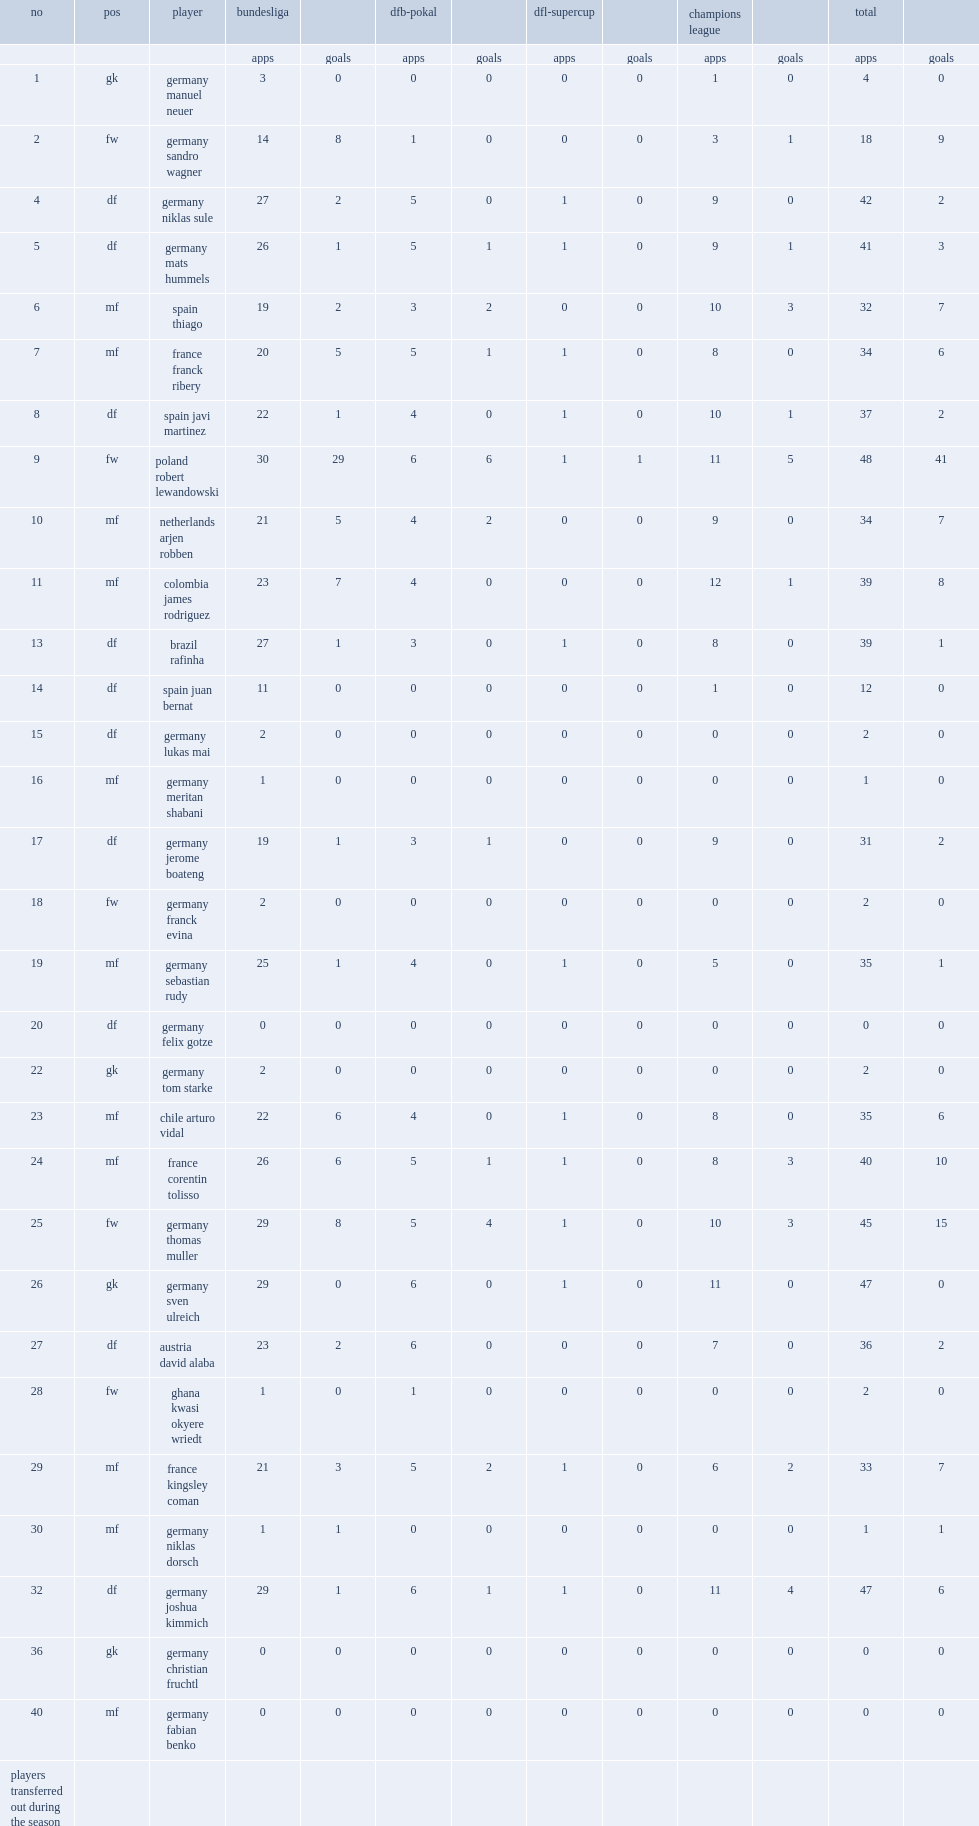What the matches did bayern play in 2007? Bundesliga dfb-pokal dfl-supercup. 